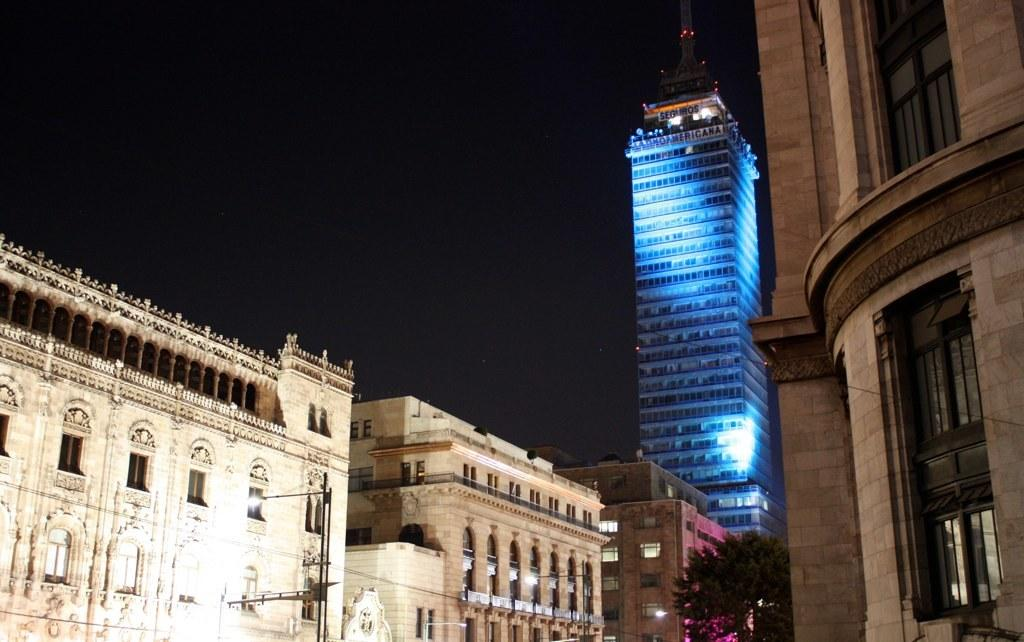What type of structures can be seen in the image? There are buildings in the image. What type of plant is present in the image? There is a tree in the image. What other objects can be seen in the image? There are poles in the image. What type of stew is being prepared by the woman in the image? There is no woman or stew present in the image. How many friends can be seen interacting with each other in the image? There are no friends or interactions between people depicted in the image. 